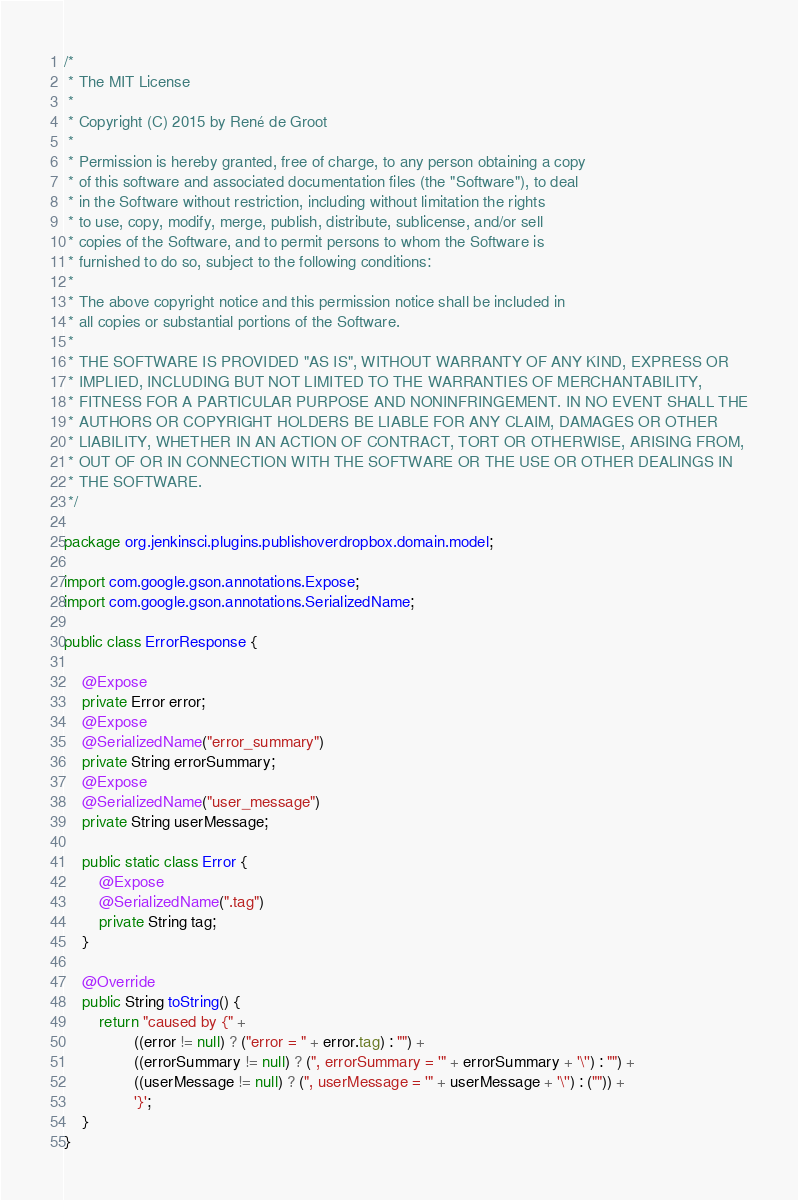Convert code to text. <code><loc_0><loc_0><loc_500><loc_500><_Java_>/*
 * The MIT License
 *
 * Copyright (C) 2015 by René de Groot
 *
 * Permission is hereby granted, free of charge, to any person obtaining a copy
 * of this software and associated documentation files (the "Software"), to deal
 * in the Software without restriction, including without limitation the rights
 * to use, copy, modify, merge, publish, distribute, sublicense, and/or sell
 * copies of the Software, and to permit persons to whom the Software is
 * furnished to do so, subject to the following conditions:
 *
 * The above copyright notice and this permission notice shall be included in
 * all copies or substantial portions of the Software.
 *
 * THE SOFTWARE IS PROVIDED "AS IS", WITHOUT WARRANTY OF ANY KIND, EXPRESS OR
 * IMPLIED, INCLUDING BUT NOT LIMITED TO THE WARRANTIES OF MERCHANTABILITY,
 * FITNESS FOR A PARTICULAR PURPOSE AND NONINFRINGEMENT. IN NO EVENT SHALL THE
 * AUTHORS OR COPYRIGHT HOLDERS BE LIABLE FOR ANY CLAIM, DAMAGES OR OTHER
 * LIABILITY, WHETHER IN AN ACTION OF CONTRACT, TORT OR OTHERWISE, ARISING FROM,
 * OUT OF OR IN CONNECTION WITH THE SOFTWARE OR THE USE OR OTHER DEALINGS IN
 * THE SOFTWARE.
 */

package org.jenkinsci.plugins.publishoverdropbox.domain.model;

import com.google.gson.annotations.Expose;
import com.google.gson.annotations.SerializedName;

public class ErrorResponse {

    @Expose
    private Error error;
    @Expose
    @SerializedName("error_summary")
    private String errorSummary;
    @Expose
    @SerializedName("user_message")
    private String userMessage;

    public static class Error {
        @Expose
        @SerializedName(".tag")
        private String tag;
    }

    @Override
    public String toString() {
        return "caused by {" +
                ((error != null) ? ("error = " + error.tag) : "") +
                ((errorSummary != null) ? (", errorSummary = '" + errorSummary + '\'') : "") +
                ((userMessage != null) ? (", userMessage = '" + userMessage + '\'') : ("")) +
                '}';
    }
}
</code> 